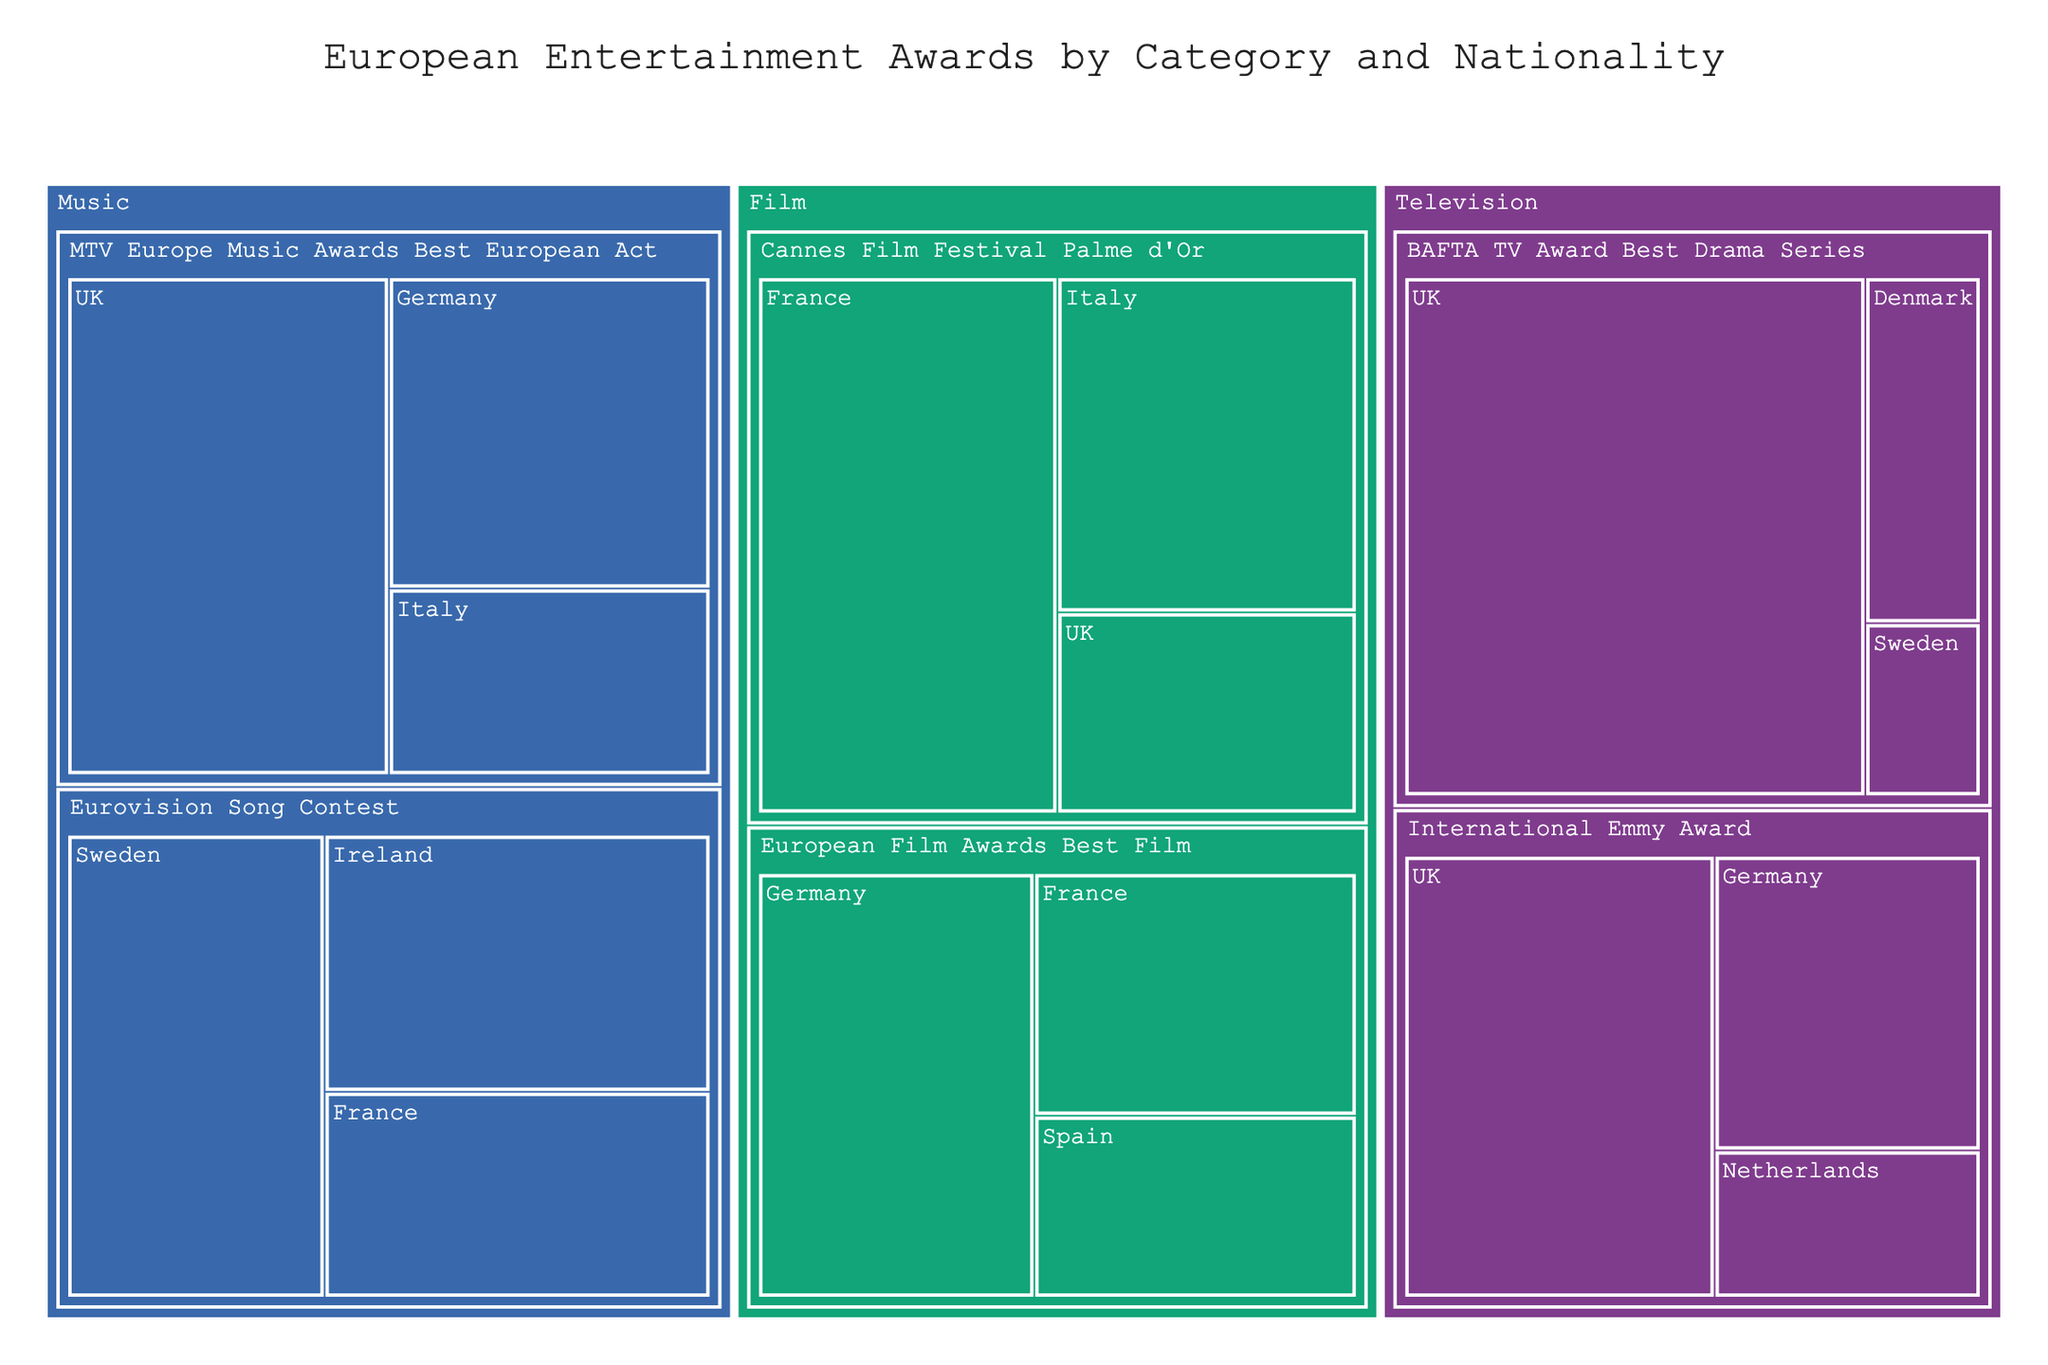How many awards has the UK won in the category of BAFTA TV Award Best Drama Series? Look at the branch labeled "BAFTA TV Award Best Drama Series" under the "Television" category. Then, find the UK under this branch. The number listed is the number of winners.
Answer: 12 Which country has won the most Cannes Film Festival Palme d'Or awards? Within the "Film" category, find the branch labeled "Cannes Film Festival Palme d'Or" and compare the number of winners for each country. The highest number determines the country with the most wins.
Answer: France What is the total number of awards won by Germany in the category of "Music"? Under the "Music" category, look for Germany in both "Eurovision Song Contest" and "MTV Europe Music Awards Best European Act". Sum the winners from both sub-categories.
Answer: 9 Which country has dominated the category "International Emmy Award" more, the UK or Germany? Within the "Television" category, find the branch labeled "International Emmy Award". Compare the number of winners for the UK and Germany.
Answer: The UK How many more awards has the UK won in "BAFTA TV Award Best Drama Series" compared to Denmark? Find the number of winners for the UK and Denmark under "BAFTA TV Award Best Drama Series" in the "Television" category. Subtract the number of winners for Denmark from the number for the UK.
Answer: 10 Which award category features the highest number of awards won by a single country, and which country is it? Inspect each award category to find the highest number of awards won by a single country.
Answer: BAFTA TV Award Best Drama Series, UK Across the "Film" category, what is the sum of awards won by France? In the "Film" category, find France in different sub-categories. Sum the number of winners in each sub-category.
Answer: 12 Is the number of Eurovision Song Contest wins by Sweden higher or lower than the number of Cannes Film Festival Palme d'Or wins by Italy? Compare the number of wins for Sweden in the "Eurovision Song Contest" and Italy in the "Cannes Film Festival Palme d'Or". Determine which number is higher or lower.
Answer: Higher What is the average number of "European Film Awards Best Film" won by countries in the "Film" category? Identify the number of winners for each country in the "European Film Awards Best Film" sub-category. Sum these numbers and divide by the number of countries.
Answer: 4.33 Which category has the most diverse range of winning nationalities? Check each main category (Film, Television, Music) and count the number of different nationalities within their sub-categories. The category with the most unique nationalities is the answer.
Answer: Television 